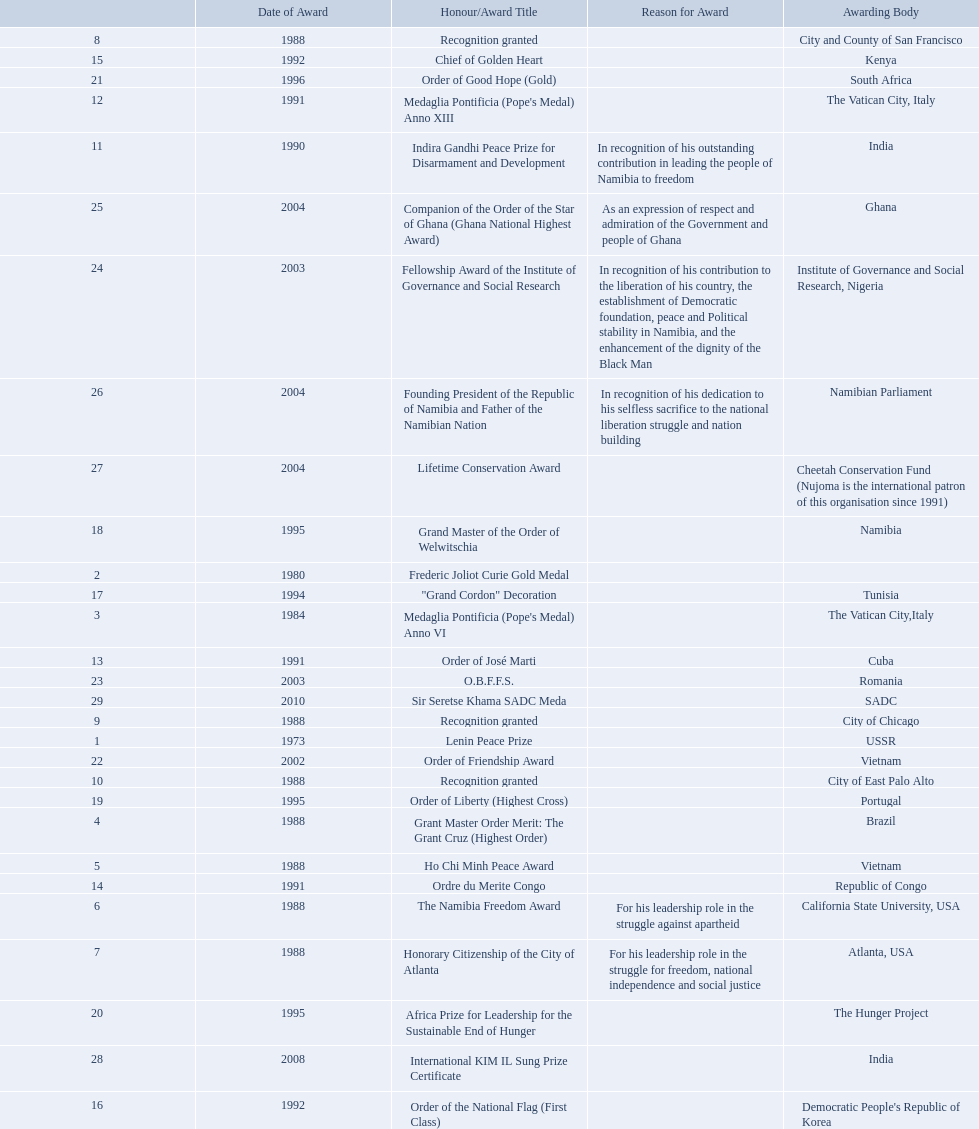Which awarding bodies have recognized sam nujoma? USSR, , The Vatican City,Italy, Brazil, Vietnam, California State University, USA, Atlanta, USA, City and County of San Francisco, City of Chicago, City of East Palo Alto, India, The Vatican City, Italy, Cuba, Republic of Congo, Kenya, Democratic People's Republic of Korea, Tunisia, Namibia, Portugal, The Hunger Project, South Africa, Vietnam, Romania, Institute of Governance and Social Research, Nigeria, Ghana, Namibian Parliament, Cheetah Conservation Fund (Nujoma is the international patron of this organisation since 1991), India, SADC. And what was the title of each award or honour? Lenin Peace Prize, Frederic Joliot Curie Gold Medal, Medaglia Pontificia (Pope's Medal) Anno VI, Grant Master Order Merit: The Grant Cruz (Highest Order), Ho Chi Minh Peace Award, The Namibia Freedom Award, Honorary Citizenship of the City of Atlanta, Recognition granted, Recognition granted, Recognition granted, Indira Gandhi Peace Prize for Disarmament and Development, Medaglia Pontificia (Pope's Medal) Anno XIII, Order of José Marti, Ordre du Merite Congo, Chief of Golden Heart, Order of the National Flag (First Class), "Grand Cordon" Decoration, Grand Master of the Order of Welwitschia, Order of Liberty (Highest Cross), Africa Prize for Leadership for the Sustainable End of Hunger, Order of Good Hope (Gold), Order of Friendship Award, O.B.F.F.S., Fellowship Award of the Institute of Governance and Social Research, Companion of the Order of the Star of Ghana (Ghana National Highest Award), Founding President of the Republic of Namibia and Father of the Namibian Nation, Lifetime Conservation Award, International KIM IL Sung Prize Certificate, Sir Seretse Khama SADC Meda. Of those, which nation awarded him the o.b.f.f.s.? Romania. 